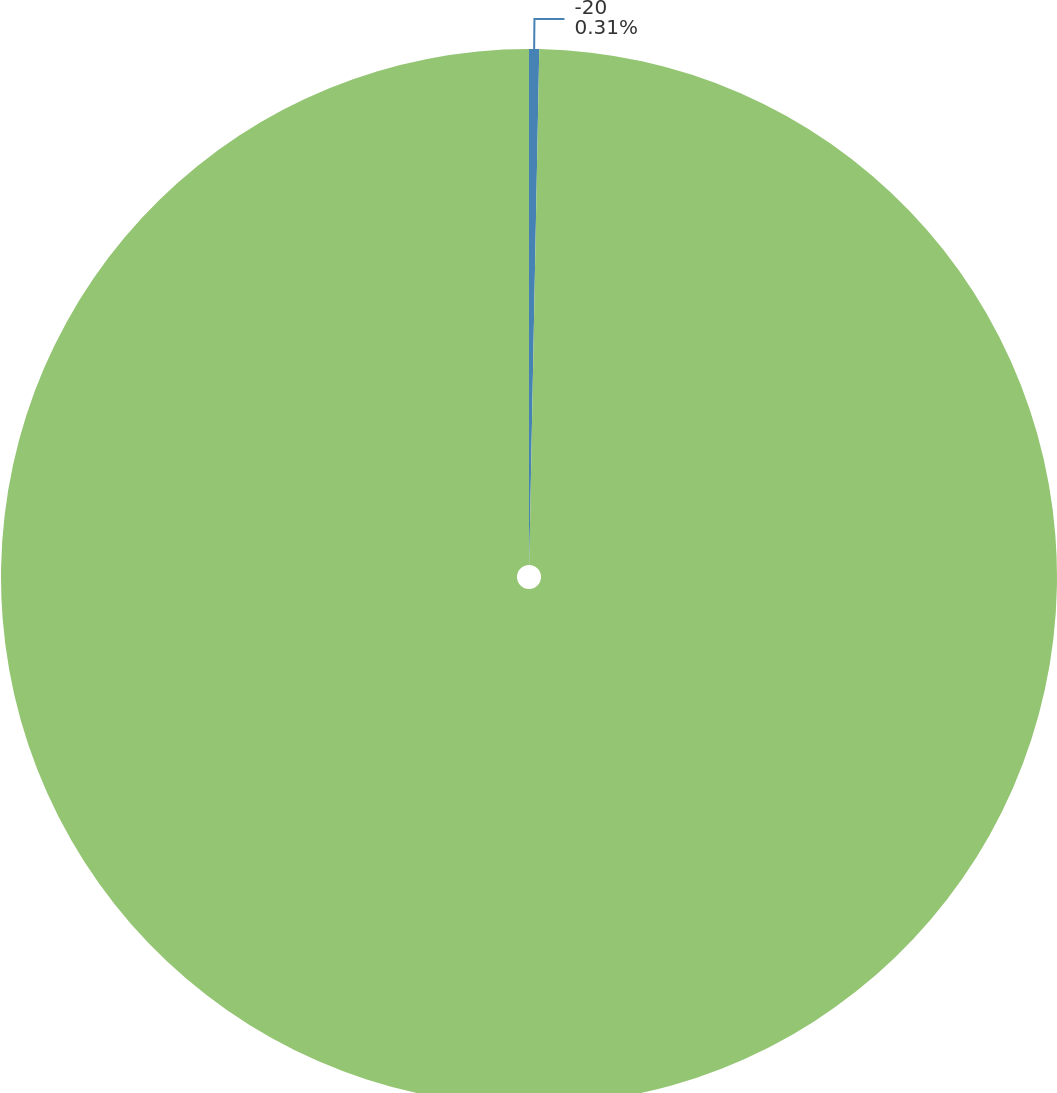Convert chart to OTSL. <chart><loc_0><loc_0><loc_500><loc_500><pie_chart><fcel>-20<fcel>8745<nl><fcel>0.31%<fcel>99.69%<nl></chart> 